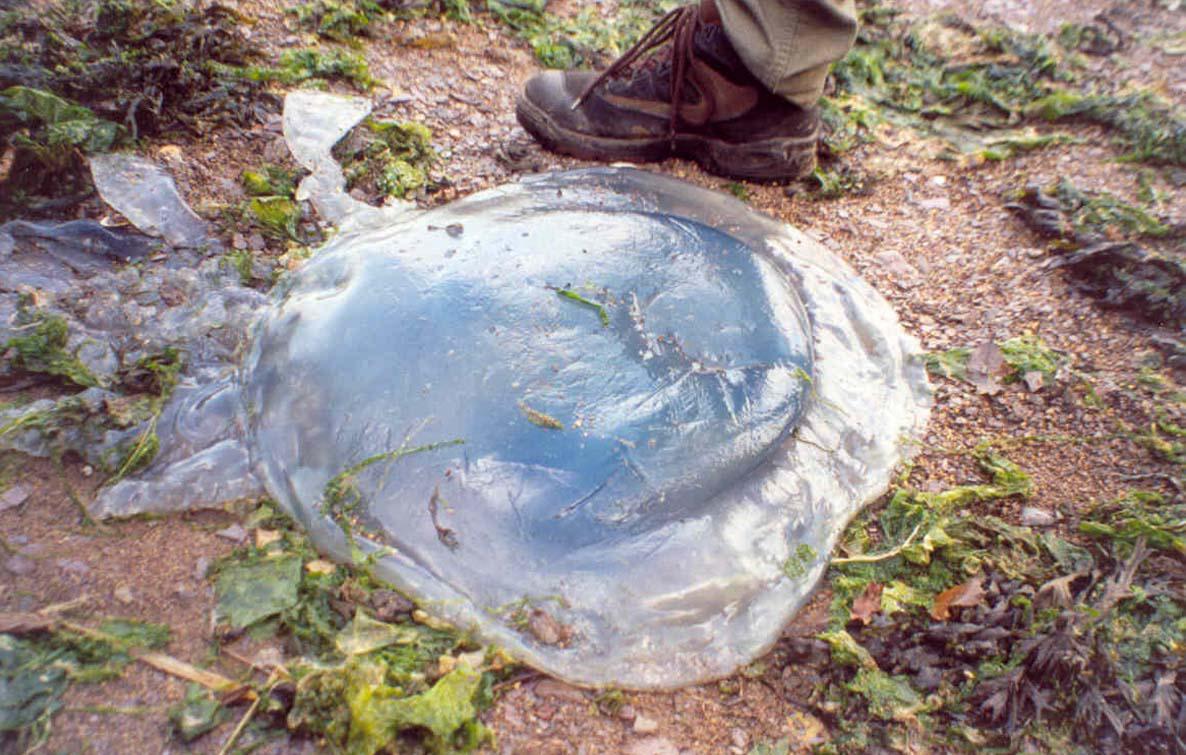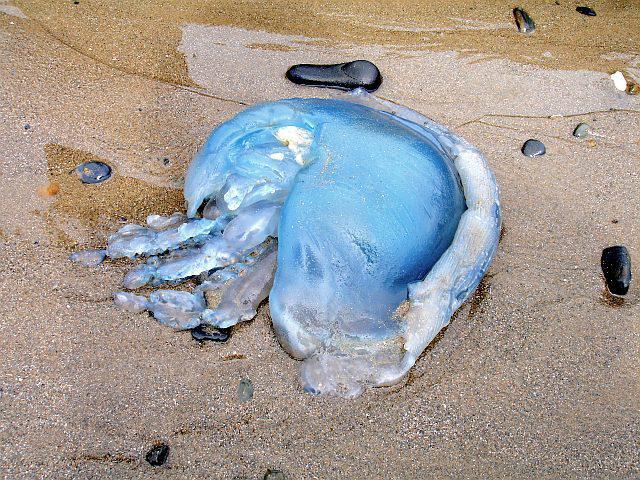The first image is the image on the left, the second image is the image on the right. Given the left and right images, does the statement "Each image shows one prominent beached jellyfish that resembles an inflated bluish translucent balloon." hold true? Answer yes or no. Yes. The first image is the image on the left, the second image is the image on the right. Given the left and right images, does the statement "Each picture only has one jellyfish." hold true? Answer yes or no. Yes. 